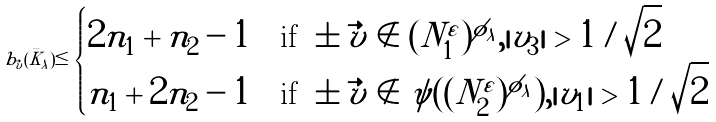<formula> <loc_0><loc_0><loc_500><loc_500>b _ { \vec { v } } ( \bar { K } _ { \lambda } ) \leq \begin{cases} 2 n _ { 1 } + n _ { 2 } - 1 & \text {if\ } \pm \vec { v } \notin ( N ^ { \varepsilon } _ { 1 } ) ^ { \phi _ { \lambda } } , | v _ { 3 } | > 1 / \sqrt { 2 } \\ n _ { 1 } + 2 n _ { 2 } - 1 & \text {if\ } \pm \vec { v } \notin \psi ( ( N ^ { \varepsilon } _ { 2 } ) ^ { \phi _ { \lambda } } ) , | v _ { 1 } | > 1 / \sqrt { 2 } \end{cases}</formula> 